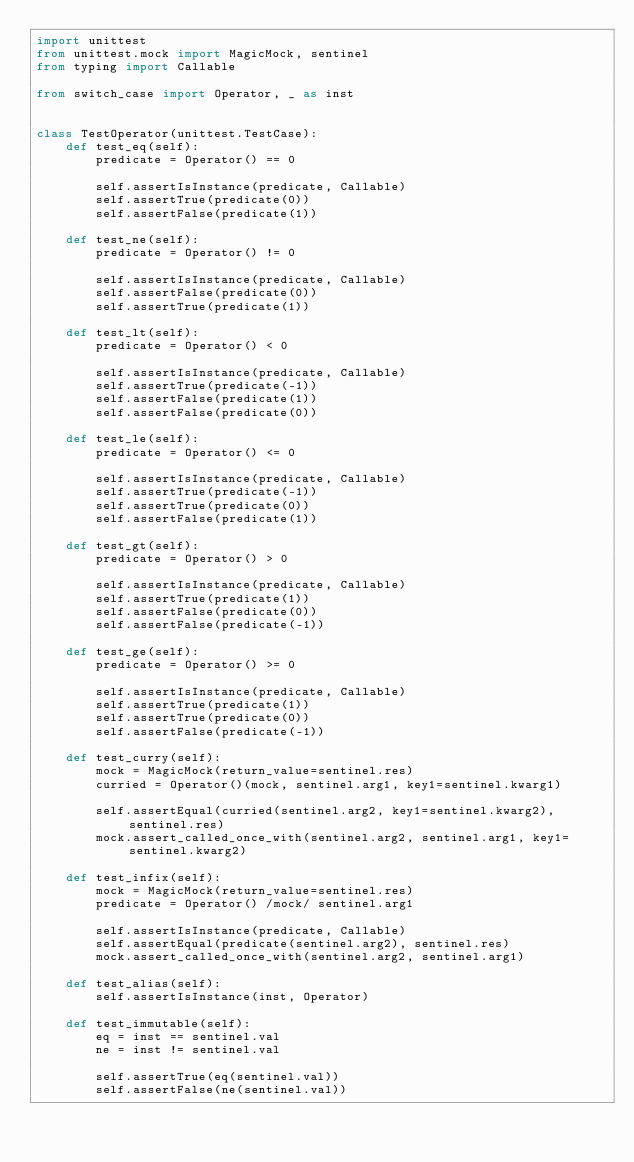Convert code to text. <code><loc_0><loc_0><loc_500><loc_500><_Python_>import unittest
from unittest.mock import MagicMock, sentinel
from typing import Callable

from switch_case import Operator, _ as inst


class TestOperator(unittest.TestCase):
    def test_eq(self):
        predicate = Operator() == 0

        self.assertIsInstance(predicate, Callable)
        self.assertTrue(predicate(0))
        self.assertFalse(predicate(1))

    def test_ne(self):
        predicate = Operator() != 0

        self.assertIsInstance(predicate, Callable)
        self.assertFalse(predicate(0))
        self.assertTrue(predicate(1))

    def test_lt(self):
        predicate = Operator() < 0

        self.assertIsInstance(predicate, Callable)
        self.assertTrue(predicate(-1))
        self.assertFalse(predicate(1))
        self.assertFalse(predicate(0))

    def test_le(self):
        predicate = Operator() <= 0

        self.assertIsInstance(predicate, Callable)
        self.assertTrue(predicate(-1))
        self.assertTrue(predicate(0))
        self.assertFalse(predicate(1))

    def test_gt(self):
        predicate = Operator() > 0

        self.assertIsInstance(predicate, Callable)
        self.assertTrue(predicate(1))
        self.assertFalse(predicate(0))
        self.assertFalse(predicate(-1))

    def test_ge(self):
        predicate = Operator() >= 0

        self.assertIsInstance(predicate, Callable)
        self.assertTrue(predicate(1))
        self.assertTrue(predicate(0))
        self.assertFalse(predicate(-1))

    def test_curry(self):
        mock = MagicMock(return_value=sentinel.res)
        curried = Operator()(mock, sentinel.arg1, key1=sentinel.kwarg1)

        self.assertEqual(curried(sentinel.arg2, key1=sentinel.kwarg2), sentinel.res)
        mock.assert_called_once_with(sentinel.arg2, sentinel.arg1, key1=sentinel.kwarg2)

    def test_infix(self):
        mock = MagicMock(return_value=sentinel.res)
        predicate = Operator() /mock/ sentinel.arg1

        self.assertIsInstance(predicate, Callable)
        self.assertEqual(predicate(sentinel.arg2), sentinel.res)
        mock.assert_called_once_with(sentinel.arg2, sentinel.arg1)

    def test_alias(self):
        self.assertIsInstance(inst, Operator)

    def test_immutable(self):
        eq = inst == sentinel.val
        ne = inst != sentinel.val

        self.assertTrue(eq(sentinel.val))
        self.assertFalse(ne(sentinel.val))
</code> 